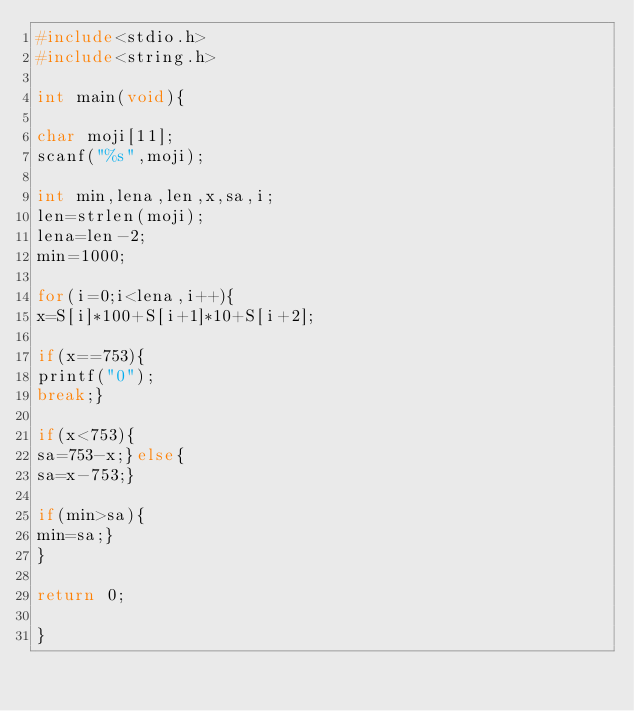Convert code to text. <code><loc_0><loc_0><loc_500><loc_500><_C_>#include<stdio.h>
#include<string.h>

int main(void){

char moji[11];
scanf("%s",moji);

int min,lena,len,x,sa,i;
len=strlen(moji);
lena=len-2;
min=1000;

for(i=0;i<lena,i++){
x=S[i]*100+S[i+1]*10+S[i+2];

if(x==753){
printf("0");
break;}

if(x<753){
sa=753-x;}else{
sa=x-753;}

if(min>sa){
min=sa;}
}

return 0;

}</code> 